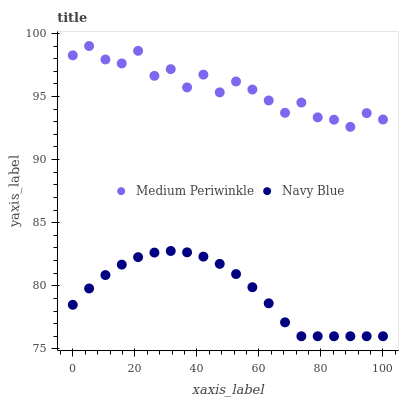Does Navy Blue have the minimum area under the curve?
Answer yes or no. Yes. Does Medium Periwinkle have the maximum area under the curve?
Answer yes or no. Yes. Does Medium Periwinkle have the minimum area under the curve?
Answer yes or no. No. Is Navy Blue the smoothest?
Answer yes or no. Yes. Is Medium Periwinkle the roughest?
Answer yes or no. Yes. Is Medium Periwinkle the smoothest?
Answer yes or no. No. Does Navy Blue have the lowest value?
Answer yes or no. Yes. Does Medium Periwinkle have the lowest value?
Answer yes or no. No. Does Medium Periwinkle have the highest value?
Answer yes or no. Yes. Is Navy Blue less than Medium Periwinkle?
Answer yes or no. Yes. Is Medium Periwinkle greater than Navy Blue?
Answer yes or no. Yes. Does Navy Blue intersect Medium Periwinkle?
Answer yes or no. No. 